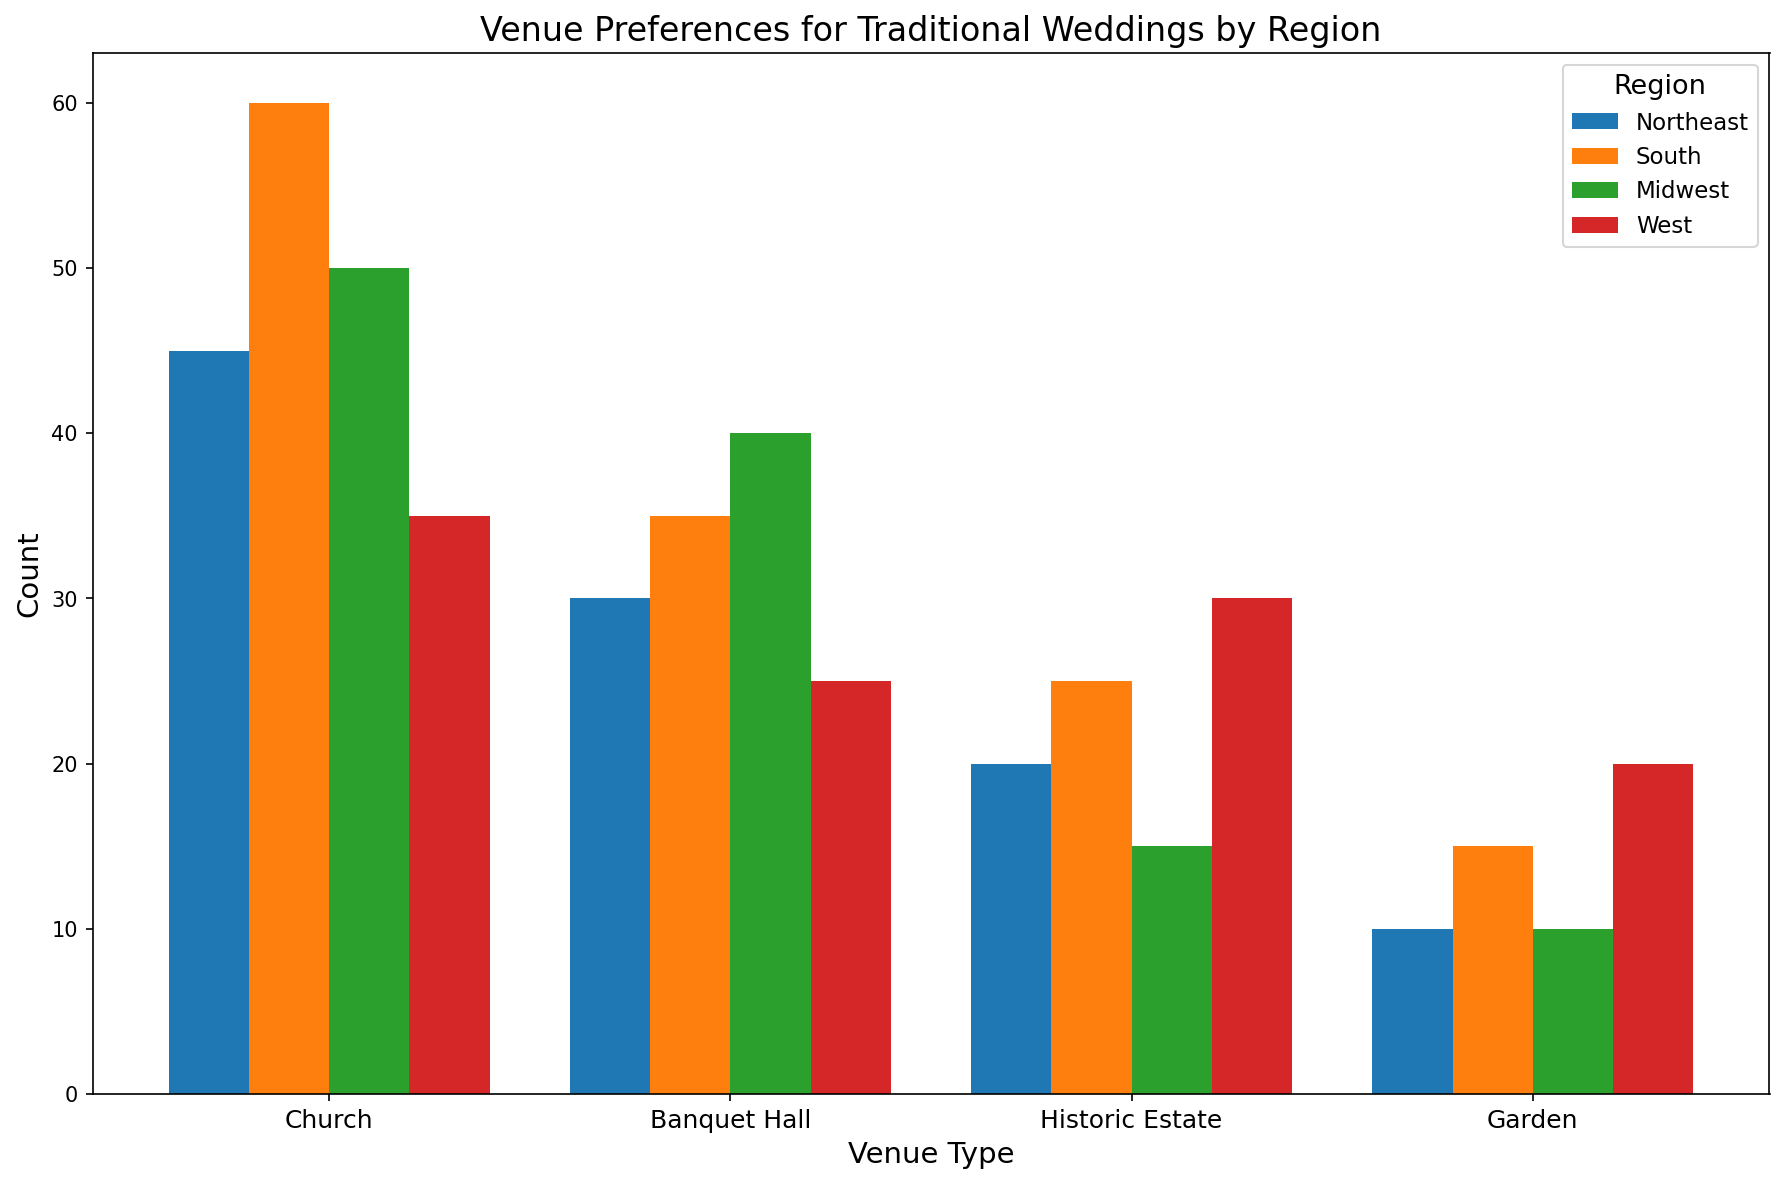How many total venues are used for traditional weddings across all regions? Sum the count of all venue types across all regions: (45+30+20+10) + (60+35+25+15) + (50+40+15+10) + (35+25+30+20) = 310
Answer: 310 Which region has the highest preference for Church venues? Compare the counts for Church venues across all the regions: Northeast (45), South (60), Midwest (50), West (35). The South has the highest count at 60.
Answer: South What is the preference difference between Historic Estates and Gardens in the Midwest? Subtract the Garden count from the Historic Estate count in the Midwest: 15 - 10 = 5
Answer: 5 Which venue type in the West region has the smallest count? Compare the counts for all venue types in the West: Church (35), Banquet Hall (25), Historic Estate (30), Garden (20). The Garden has the smallest count at 20.
Answer: Garden How does the preference for Banquet Halls in the Midwest compare to that in the Northeast? Compare the counts for Banquet Halls in both regions: Midwest (40), Northeast (30). The Midwest has a higher count of 40 compared to 30 in the Northeast.
Answer: Midwest What is the total count of Church venues in the Northeast and South combined? Add Church counts from both regions: Northeast (45), South (60). 45 + 60 = 105
Answer: 105 Which region has the least preference for Garden venues? Compare the counts for Garden venues across all regions: Northeast (10), South (15), Midwest (10), West (20). Either Northeast or Midwest could be correct as both have a count of 10.
Answer: Northeast or Midwest What’s the average count of Banquet Halls across all regions? Calculate the average count of Banquet Halls across all regions: (30 + 35 + 40 + 25) / 4 = 32.5
Answer: 32.5 